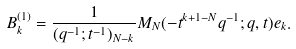Convert formula to latex. <formula><loc_0><loc_0><loc_500><loc_500>B _ { k } ^ { ( 1 ) } = \frac { 1 } { ( q ^ { - 1 } ; t ^ { - 1 } ) _ { N - k } } M _ { N } ( - t ^ { k + 1 - N } q ^ { - 1 } ; q , t ) e _ { k } .</formula> 